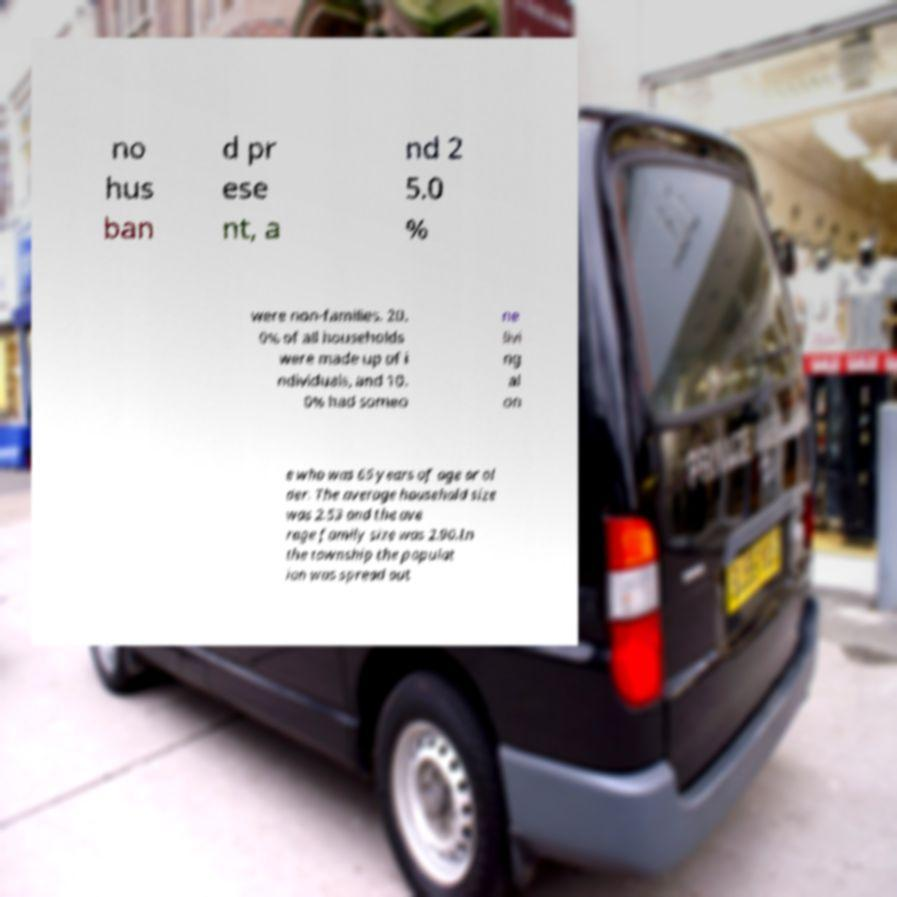Please identify and transcribe the text found in this image. no hus ban d pr ese nt, a nd 2 5.0 % were non-families. 20. 0% of all households were made up of i ndividuals, and 10. 0% had someo ne livi ng al on e who was 65 years of age or ol der. The average household size was 2.53 and the ave rage family size was 2.90.In the township the populat ion was spread out 